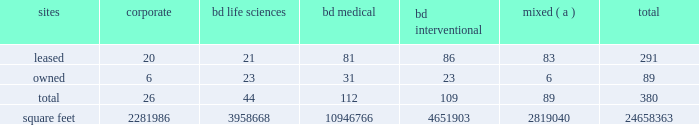Agreements containing cross-default provisions .
Under these circumstances , we might not have sufficient funds or other resources to satisfy all of our obligations .
The mandatory convertible preferred stock underlying the depositary shares issued in connection with the financing of the bard transaction may adversely affect the market price of bd common stock .
The market price of bd common stock is likely to be influenced by the mandatory convertible preferred stock underlying the depositary shares issued in connection with the financing for the bard transaction .
The market price of bd common stock could become more volatile and could be depressed by : 2022 investors 2019 anticipation of the potential resale in the market of a substantial number of additional shares of bd common stock received upon conversion of the mandatory convertible preferred stock ; 2022 possible sales of bd common stock by investors who view the mandatory convertible preferred stock as a more attractive means of equity participation in bd than owning shares of bd common stock ; and 2022 hedging or arbitrage trading activity that may develop involving the mandatory convertible preferred stock and bd common stock .
Item 1b .
Unresolved staff comments .
Item 2 .
Properties .
Bd 2019s executive offices are located in franklin lakes , new jersey .
As of october 31 , 2018 , bd owned or leased 380 facilities throughout the world , comprising approximately 24658363 square feet of manufacturing , warehousing , administrative and research facilities .
The u.s .
Facilities , including those in puerto rico , comprise approximately 8619099 square feet of owned and 4407539 square feet of leased space .
The international facilities comprise approximately 8484223 square feet of owned and 3147502 square feet of leased space .
Sales offices and distribution centers included in the total square footage are also located throughout the world .
Operations in each of bd 2019s business segments are conducted at both u.s .
And international locations .
Particularly in the international marketplace , facilities often serve more than one business segment and are used for multiple purposes , such as administrative/sales , manufacturing and/or warehousing/distribution .
Bd generally seeks to own its manufacturing facilities , although some are leased .
The table summarizes property information by business segment. .
( a ) facilities used by more than one business segment .
Bd believes that its facilities are of good construction and in good physical condition , are suitable and adequate for the operations conducted at those facilities , and are , with minor exceptions , fully utilized and operating at normal capacity .
The u.s .
Facilities are located in alabama , arizona , california , connecticut , florida , georgia , illinois , indiana , maryland , massachusetts , michigan , minnesota , missouri , montana , nebraska , new jersey , new york , north carolina , ohio , oklahoma , oregon , pennsylvania , rhode island , south carolina , tennessee , texas , utah , virginia , washington , d.c. , washington , wisconsin and puerto rico. .
As of october 31 , 2018 , what was the average square footage per location bd owned or leased in square feet .? 
Computations: (24658363 / 380)
Answer: 64890.42895. 